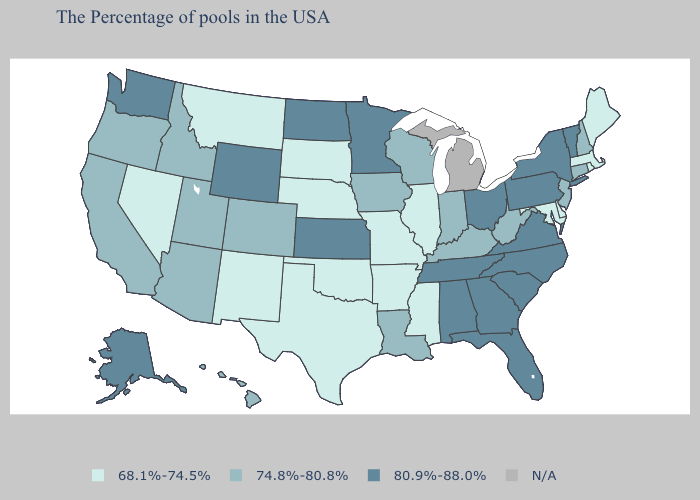What is the lowest value in states that border Kansas?
Short answer required. 68.1%-74.5%. Among the states that border Iowa , which have the highest value?
Concise answer only. Minnesota. What is the value of Arkansas?
Give a very brief answer. 68.1%-74.5%. What is the value of Wyoming?
Short answer required. 80.9%-88.0%. Name the states that have a value in the range 80.9%-88.0%?
Concise answer only. Vermont, New York, Pennsylvania, Virginia, North Carolina, South Carolina, Ohio, Florida, Georgia, Alabama, Tennessee, Minnesota, Kansas, North Dakota, Wyoming, Washington, Alaska. What is the value of Delaware?
Write a very short answer. 68.1%-74.5%. What is the value of Maryland?
Short answer required. 68.1%-74.5%. Which states have the lowest value in the USA?
Concise answer only. Maine, Massachusetts, Rhode Island, Delaware, Maryland, Illinois, Mississippi, Missouri, Arkansas, Nebraska, Oklahoma, Texas, South Dakota, New Mexico, Montana, Nevada. Name the states that have a value in the range 68.1%-74.5%?
Short answer required. Maine, Massachusetts, Rhode Island, Delaware, Maryland, Illinois, Mississippi, Missouri, Arkansas, Nebraska, Oklahoma, Texas, South Dakota, New Mexico, Montana, Nevada. Does the first symbol in the legend represent the smallest category?
Be succinct. Yes. Name the states that have a value in the range 74.8%-80.8%?
Give a very brief answer. New Hampshire, Connecticut, New Jersey, West Virginia, Kentucky, Indiana, Wisconsin, Louisiana, Iowa, Colorado, Utah, Arizona, Idaho, California, Oregon, Hawaii. What is the value of New Jersey?
Concise answer only. 74.8%-80.8%. What is the value of Washington?
Answer briefly. 80.9%-88.0%. Name the states that have a value in the range 68.1%-74.5%?
Answer briefly. Maine, Massachusetts, Rhode Island, Delaware, Maryland, Illinois, Mississippi, Missouri, Arkansas, Nebraska, Oklahoma, Texas, South Dakota, New Mexico, Montana, Nevada. 